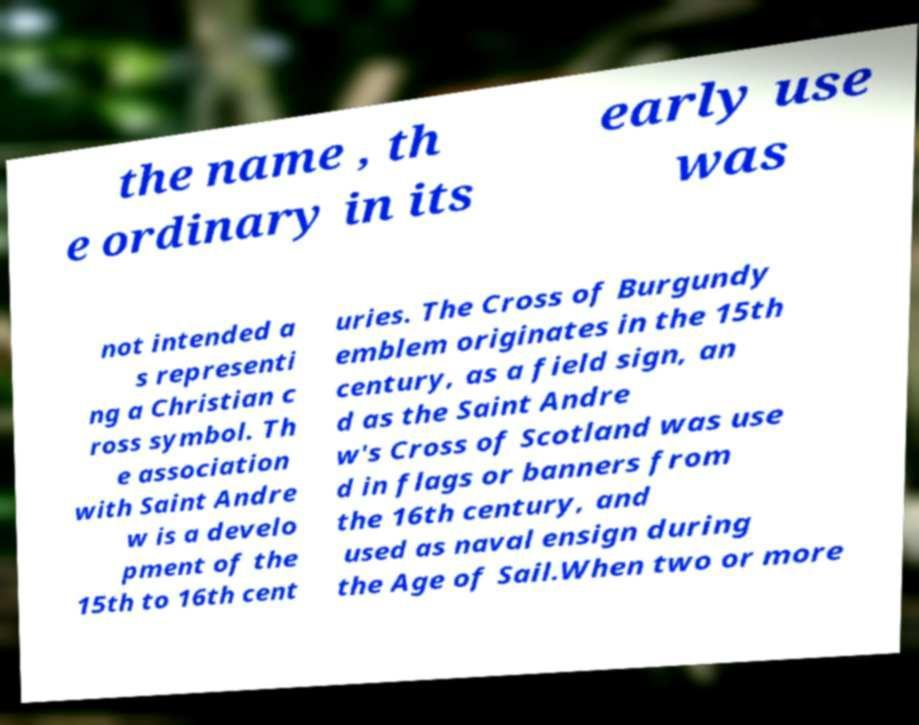Could you extract and type out the text from this image? the name , th e ordinary in its early use was not intended a s representi ng a Christian c ross symbol. Th e association with Saint Andre w is a develo pment of the 15th to 16th cent uries. The Cross of Burgundy emblem originates in the 15th century, as a field sign, an d as the Saint Andre w's Cross of Scotland was use d in flags or banners from the 16th century, and used as naval ensign during the Age of Sail.When two or more 